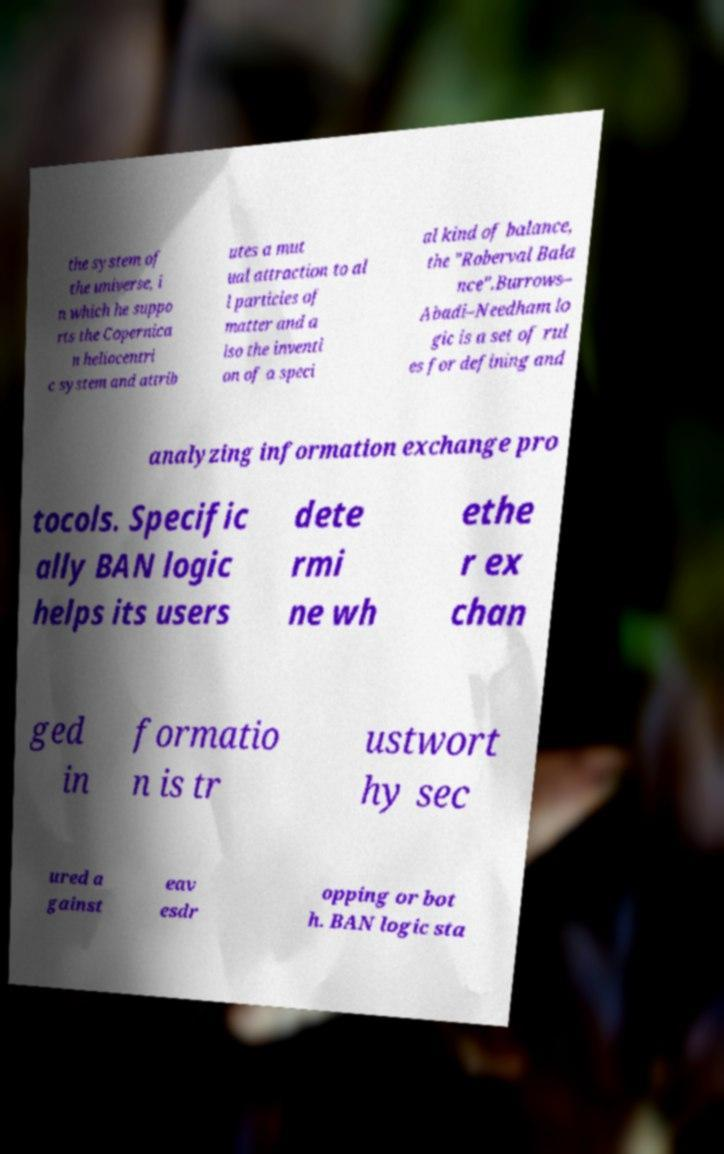I need the written content from this picture converted into text. Can you do that? the system of the universe, i n which he suppo rts the Copernica n heliocentri c system and attrib utes a mut ual attraction to al l particles of matter and a lso the inventi on of a speci al kind of balance, the "Roberval Bala nce".Burrows– Abadi–Needham lo gic is a set of rul es for defining and analyzing information exchange pro tocols. Specific ally BAN logic helps its users dete rmi ne wh ethe r ex chan ged in formatio n is tr ustwort hy sec ured a gainst eav esdr opping or bot h. BAN logic sta 